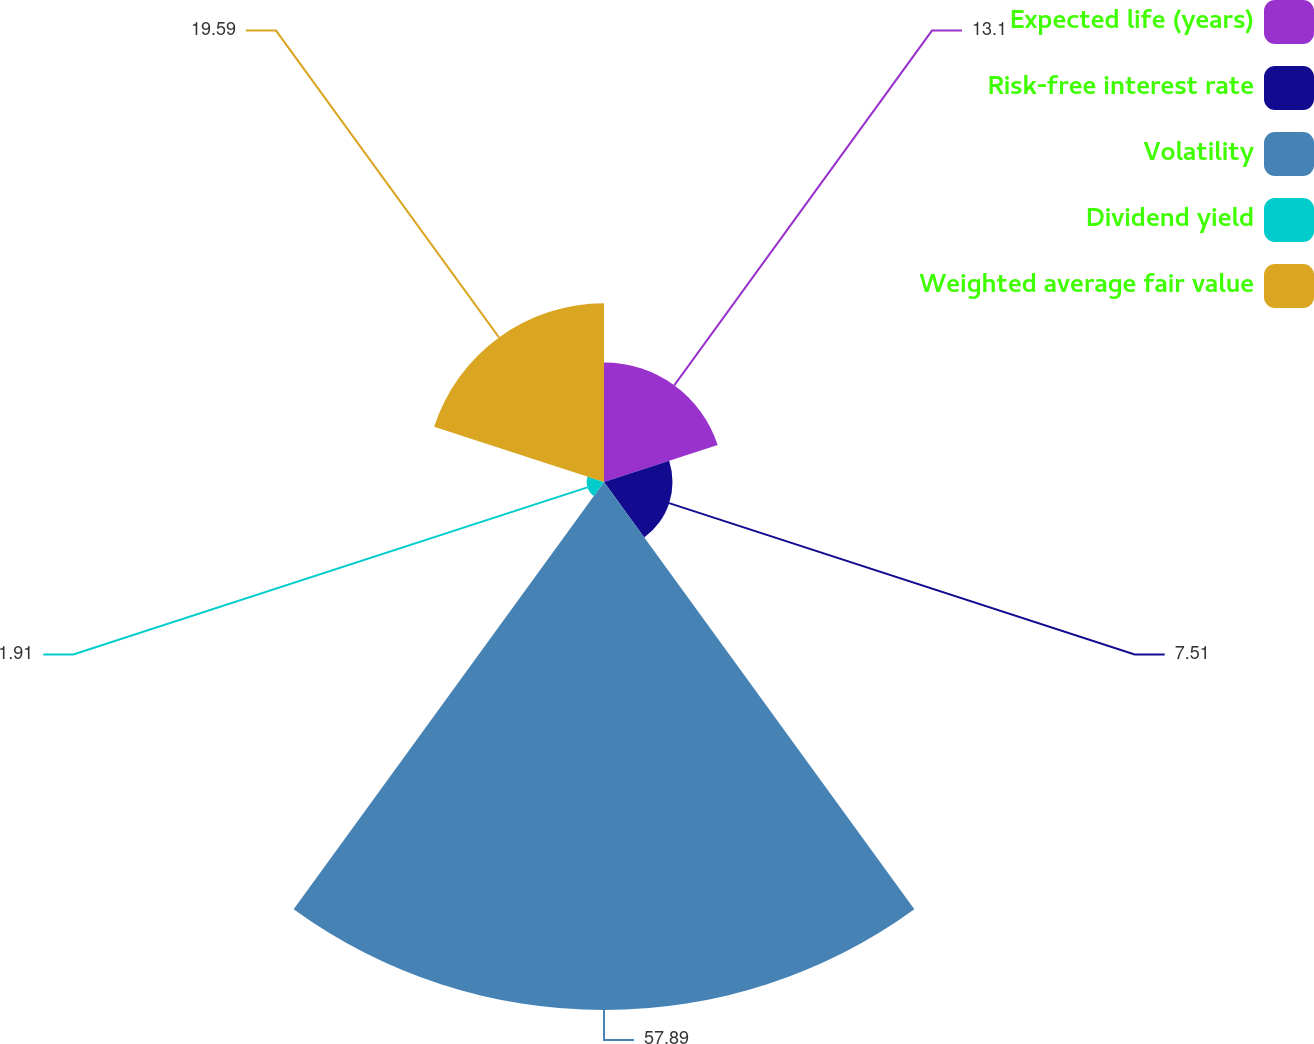<chart> <loc_0><loc_0><loc_500><loc_500><pie_chart><fcel>Expected life (years)<fcel>Risk-free interest rate<fcel>Volatility<fcel>Dividend yield<fcel>Weighted average fair value<nl><fcel>13.1%<fcel>7.51%<fcel>57.89%<fcel>1.91%<fcel>19.59%<nl></chart> 